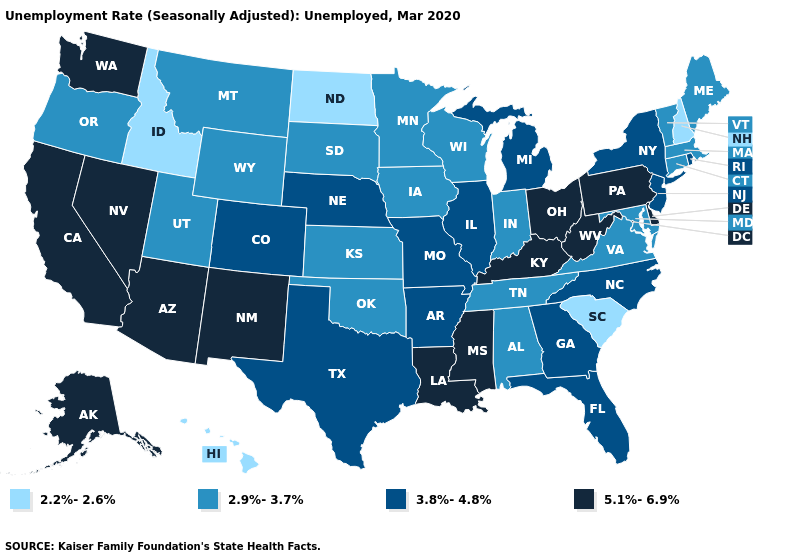Does Arizona have the highest value in the USA?
Answer briefly. Yes. What is the value of Alaska?
Concise answer only. 5.1%-6.9%. Which states have the lowest value in the South?
Keep it brief. South Carolina. Which states have the lowest value in the USA?
Quick response, please. Hawaii, Idaho, New Hampshire, North Dakota, South Carolina. Name the states that have a value in the range 2.2%-2.6%?
Concise answer only. Hawaii, Idaho, New Hampshire, North Dakota, South Carolina. Among the states that border Tennessee , does Georgia have the highest value?
Concise answer only. No. What is the value of Virginia?
Give a very brief answer. 2.9%-3.7%. What is the value of Tennessee?
Keep it brief. 2.9%-3.7%. Name the states that have a value in the range 2.2%-2.6%?
Give a very brief answer. Hawaii, Idaho, New Hampshire, North Dakota, South Carolina. Among the states that border New Jersey , which have the lowest value?
Short answer required. New York. What is the lowest value in the USA?
Give a very brief answer. 2.2%-2.6%. Is the legend a continuous bar?
Be succinct. No. What is the value of Kansas?
Concise answer only. 2.9%-3.7%. Which states have the highest value in the USA?
Answer briefly. Alaska, Arizona, California, Delaware, Kentucky, Louisiana, Mississippi, Nevada, New Mexico, Ohio, Pennsylvania, Washington, West Virginia. What is the highest value in the Northeast ?
Give a very brief answer. 5.1%-6.9%. 